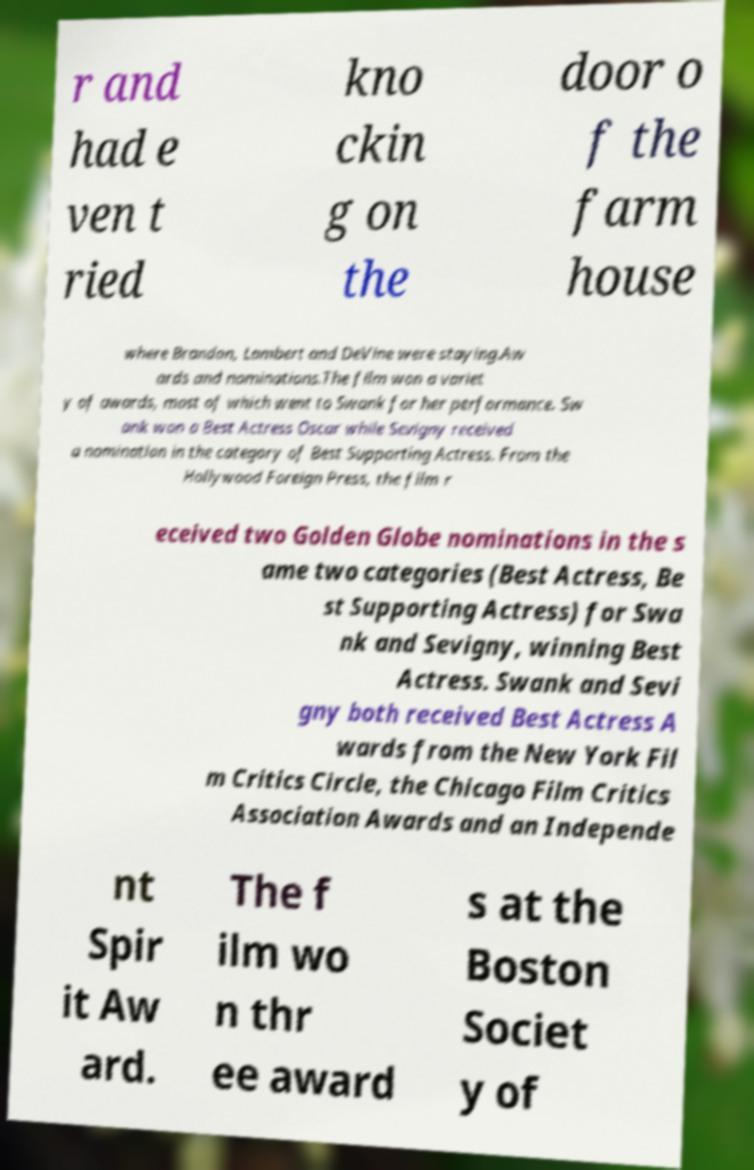Could you assist in decoding the text presented in this image and type it out clearly? r and had e ven t ried kno ckin g on the door o f the farm house where Brandon, Lambert and DeVine were staying.Aw ards and nominations.The film won a variet y of awards, most of which went to Swank for her performance. Sw ank won a Best Actress Oscar while Sevigny received a nomination in the category of Best Supporting Actress. From the Hollywood Foreign Press, the film r eceived two Golden Globe nominations in the s ame two categories (Best Actress, Be st Supporting Actress) for Swa nk and Sevigny, winning Best Actress. Swank and Sevi gny both received Best Actress A wards from the New York Fil m Critics Circle, the Chicago Film Critics Association Awards and an Independe nt Spir it Aw ard. The f ilm wo n thr ee award s at the Boston Societ y of 